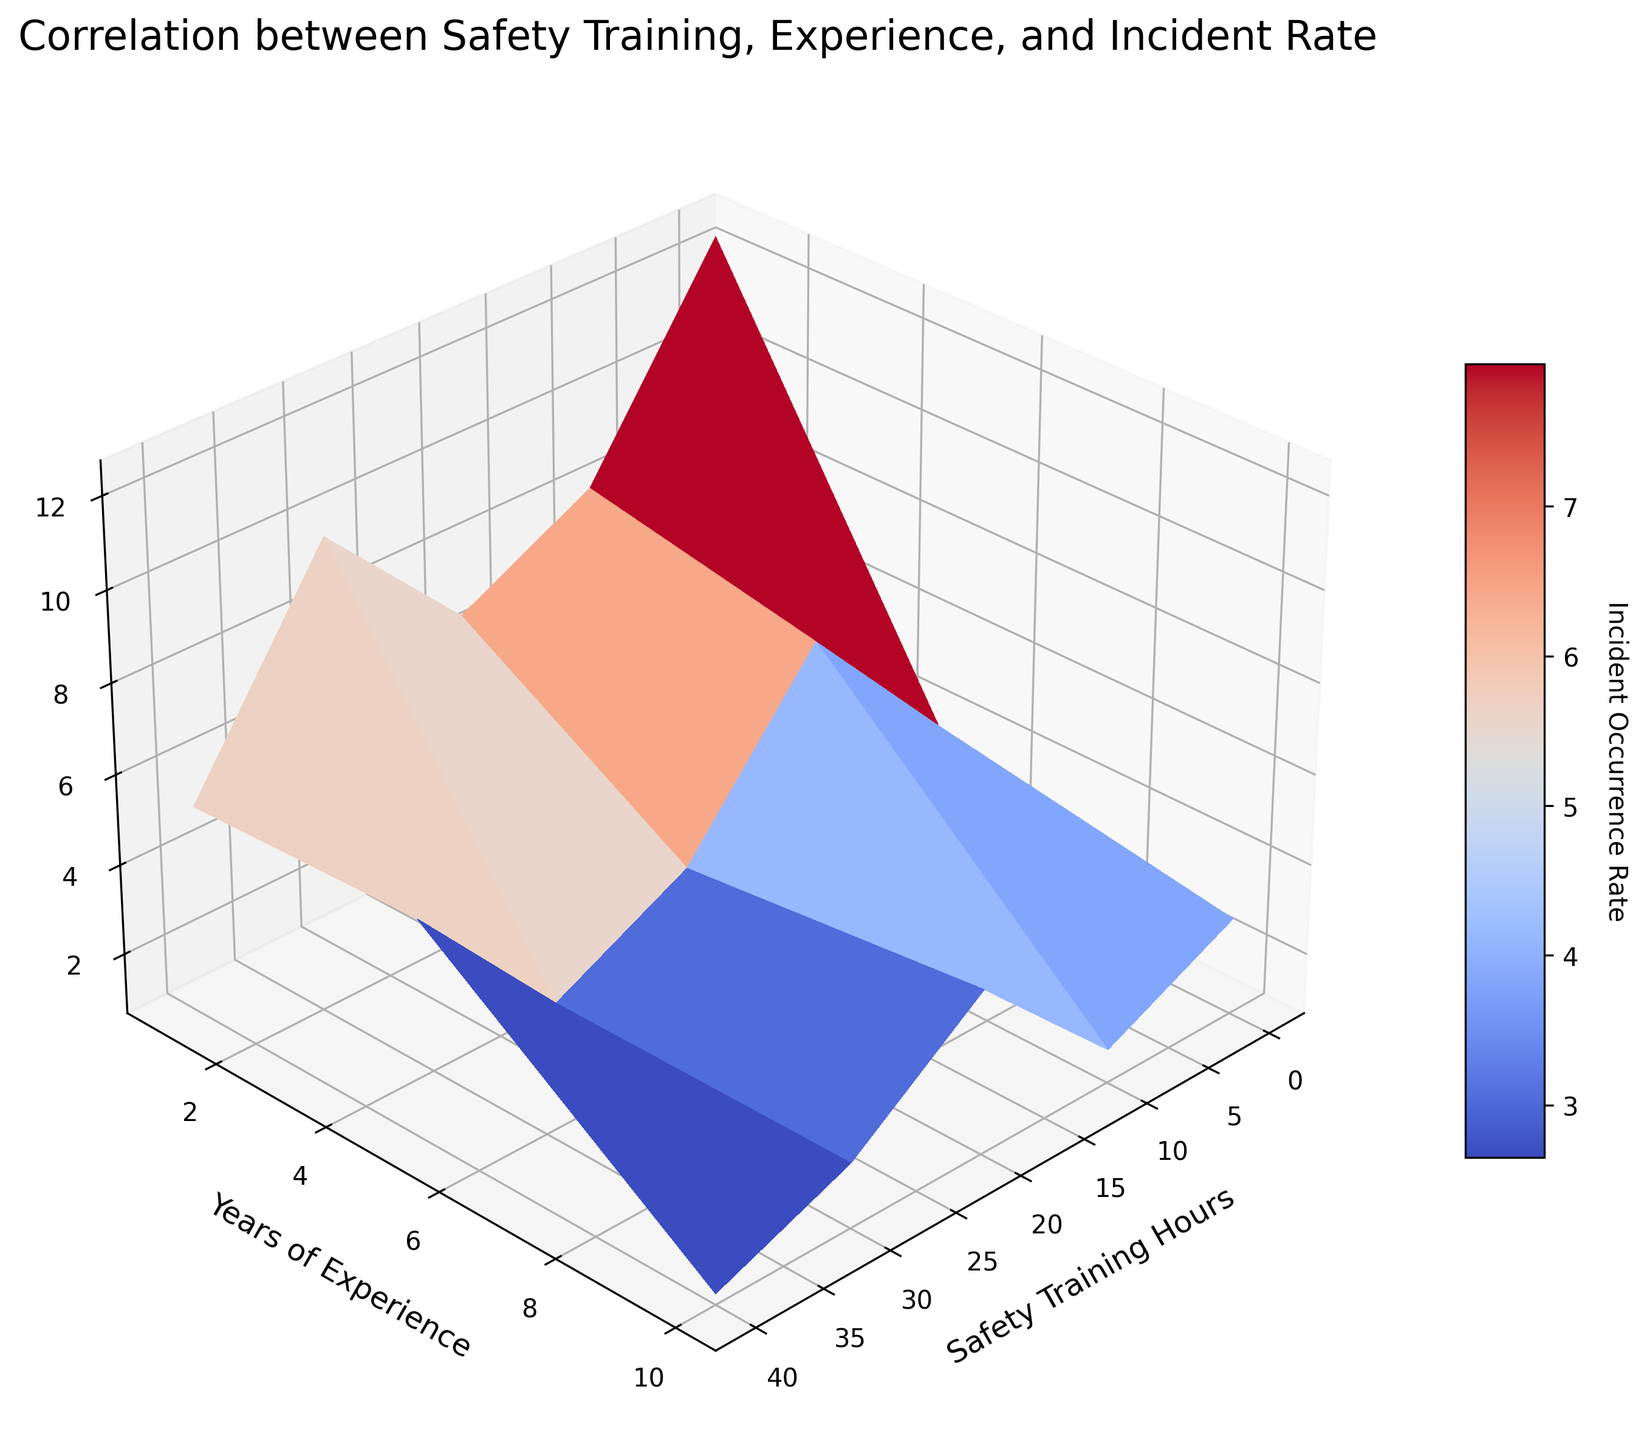What's the title of the figure? The title of the figure is displayed at the top and reads "Correlation between Safety Training, Experience, and Incident Rate".
Answer: Correlation between Safety Training, Experience, and Incident Rate How many axes labels are there and what do they say? There are three axes labels. They say "Safety Training Hours" (x-axis), "Years of Experience" (y-axis), and "Incident Occurrence Rate" (z-axis).
Answer: Three: Safety Training Hours, Years of Experience, Incident Occurrence Rate At what value of Safety Training Hours and Years of Experience is the Incident Occurrence Rate lowest? To find the lowest Incident Occurrence Rate, look for the lowest point on the z-axis which also corresponds to values on the x and y axes. It seems when Safety Training Hours is 40 and Years of Experience is 10, the Incident Occurrence Rate is lowest.
Answer: Safety Training Hours: 40, Years of Experience: 10 What is the range of Incident Occurrence Rates shown in the color bar? The range can be determined from the color bar on the right side of the figure. The lowest rate starts from 0.9 and the highest goes up to 12.5.
Answer: 0.9 to 12.5 Does increasing Safety Training Hours always reduce the Incident Occurrence Rate for any given Years of Experience? Examine the surface plot. The trend shows downward movement as Safety Training Hours increase, suggesting that increased training generally lowers the Incident Occurrence Rate regardless of the Years of Experience.
Answer: Yes How does the Incident Occurrence Rate for 10 Years of Experience compare across different Safety Training Hours? For 10 Years of Experience, observe the z-axis values as Safety Training Hours increase. Initially high at low training hours, the rate decreases progressively with increased training hours.
Answer: Decreases What Incident Occurrence Rate can you expect with 20 Safety Training Hours and 5 Years of Experience? Locate the point on the surface plot where Safety Training Hours is 20 and Years of Experience is 5. The corresponding Incident Occurrence Rate at this intersection is around 3.6.
Answer: 3.6 Is there a greater reduction in Incident Occurrence Rate as Years of Experience increase or as Safety Training Hours increase? Assess the slopes on the surface plot. Both factors contribute to reductions, but Safety Training Hours show a more dramatic drop across all levels of experience, suggesting it has a greater impact.
Answer: Safety Training Hours What's the difference in Incident Occurrence Rate between 30 and 40 Safety Training Hours for workers with 1 Year of Experience? Find Incident Occurrence Rates at 30 and 40 Safety Training Hours with 1 Year of Experience on the surface. Rates are approximately 5.5 and 4.3 respectively. The difference is 5.5 - 4.3.
Answer: 1.2 